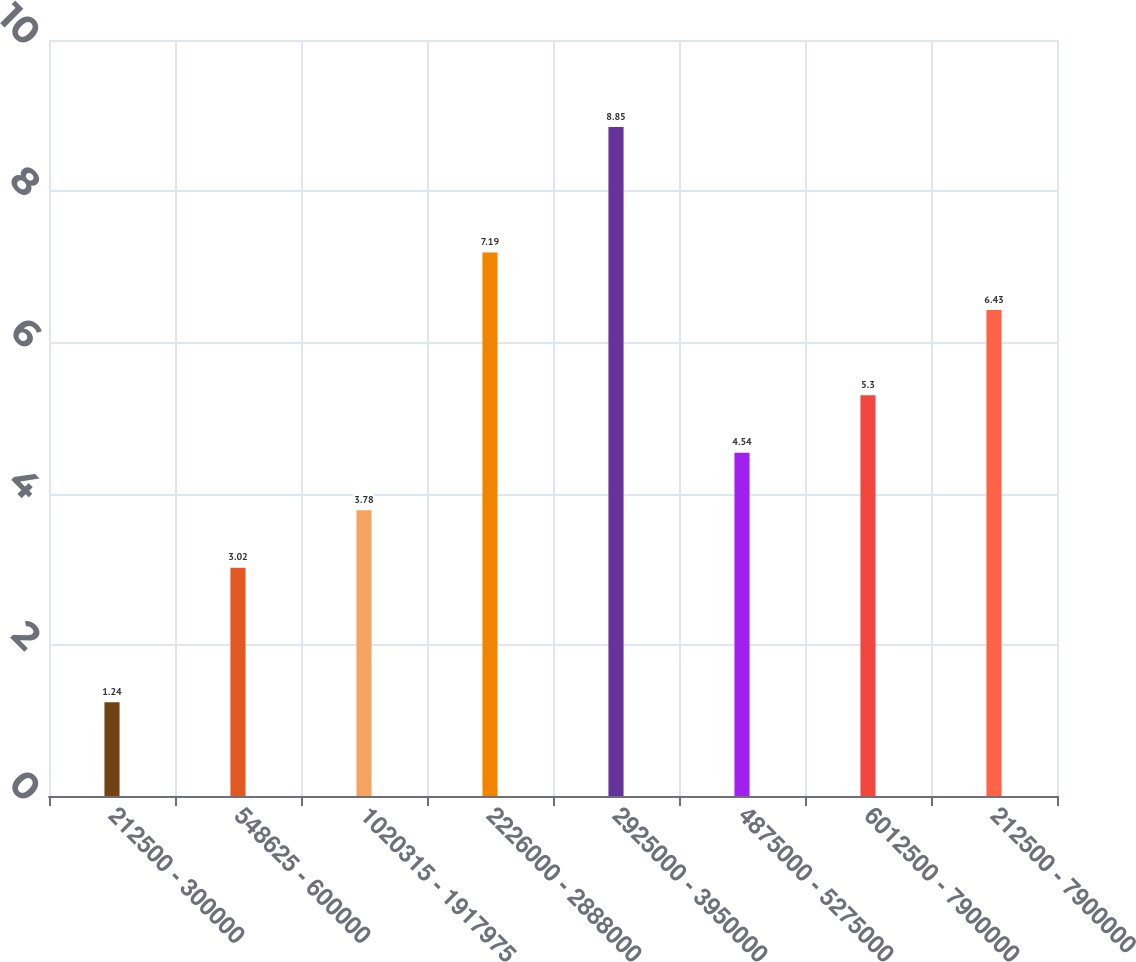Convert chart. <chart><loc_0><loc_0><loc_500><loc_500><bar_chart><fcel>212500 - 300000<fcel>548625 - 600000<fcel>1020315 - 1917975<fcel>2226000 - 2888000<fcel>2925000 - 3950000<fcel>4875000 - 5275000<fcel>6012500 - 7900000<fcel>212500 - 7900000<nl><fcel>1.24<fcel>3.02<fcel>3.78<fcel>7.19<fcel>8.85<fcel>4.54<fcel>5.3<fcel>6.43<nl></chart> 